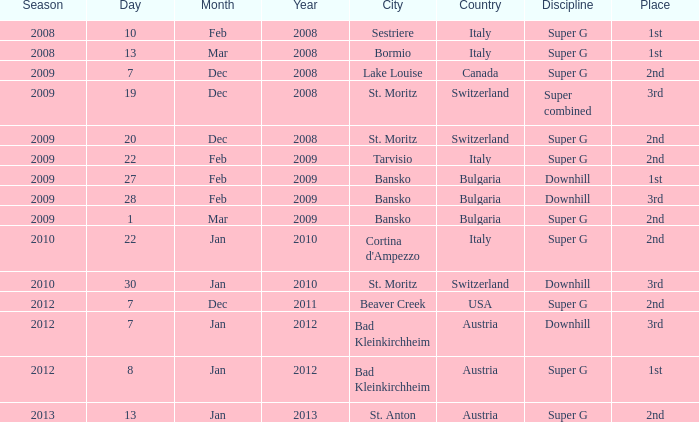What is the date of Super G in the 2010 season? 22 Jan 2010. 